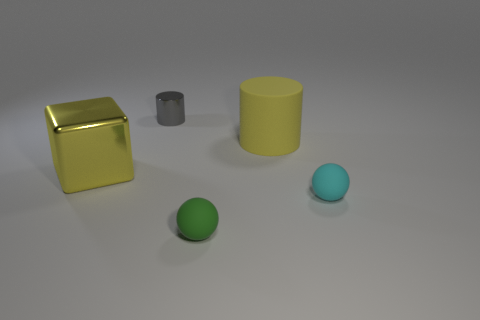Are there any blue blocks that have the same size as the yellow matte object?
Provide a succinct answer. No. There is a yellow block that is the same size as the yellow rubber cylinder; what material is it?
Give a very brief answer. Metal. The object that is both to the left of the large matte thing and behind the cube has what shape?
Give a very brief answer. Cylinder. There is a cylinder right of the tiny gray cylinder; what is its color?
Make the answer very short. Yellow. What size is the rubber object that is in front of the big yellow rubber object and on the left side of the cyan sphere?
Ensure brevity in your answer.  Small. Do the green thing and the cylinder to the right of the green ball have the same material?
Ensure brevity in your answer.  Yes. What number of big gray matte things are the same shape as the cyan object?
Your response must be concise. 0. What is the material of the other large object that is the same color as the big matte thing?
Offer a very short reply. Metal. How many big red matte spheres are there?
Offer a terse response. 0. There is a tiny green thing; is it the same shape as the small object to the right of the green rubber sphere?
Your answer should be very brief. Yes. 